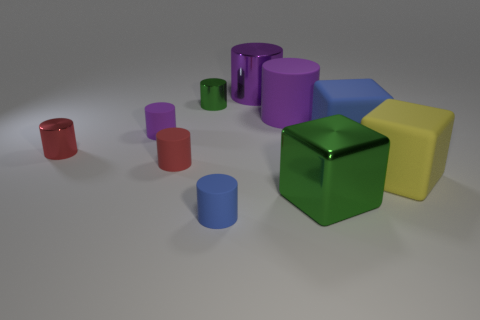Do the red matte object and the yellow thing have the same size?
Ensure brevity in your answer.  No. There is a blue object that is the same shape as the large yellow matte object; what is its material?
Provide a succinct answer. Rubber. What number of cylinders are either purple matte objects or small red matte objects?
Your response must be concise. 3. Do the purple rubber thing to the left of the small blue rubber object and the red metallic object have the same shape?
Provide a succinct answer. Yes. What is the color of the big rubber cylinder?
Provide a succinct answer. Purple. There is a large metallic object that is the same shape as the small blue thing; what is its color?
Your answer should be very brief. Purple. What number of large matte things are the same shape as the tiny green shiny object?
Ensure brevity in your answer.  1. What number of objects are blue cubes or tiny things that are behind the small blue object?
Make the answer very short. 5. Does the big metallic block have the same color as the big cylinder that is to the right of the large purple metal cylinder?
Offer a very short reply. No. How big is the metallic cylinder that is both behind the blue matte cube and in front of the big purple metal cylinder?
Offer a very short reply. Small. 